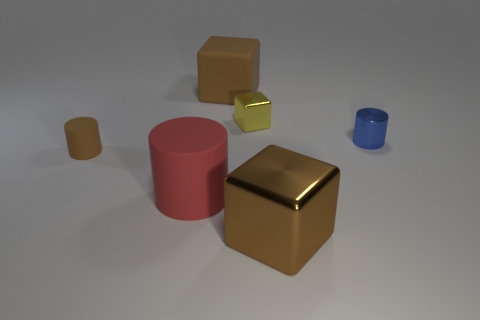Does the blue object have the same shape as the rubber thing that is behind the brown cylinder? The blue object, which appears to be a small cylinder, does not have the same shape as the rubber item behind the brown cylinder. The rubber item seems to be a small square pad or block, which is different in shape compared to the cylindrical blue object. 